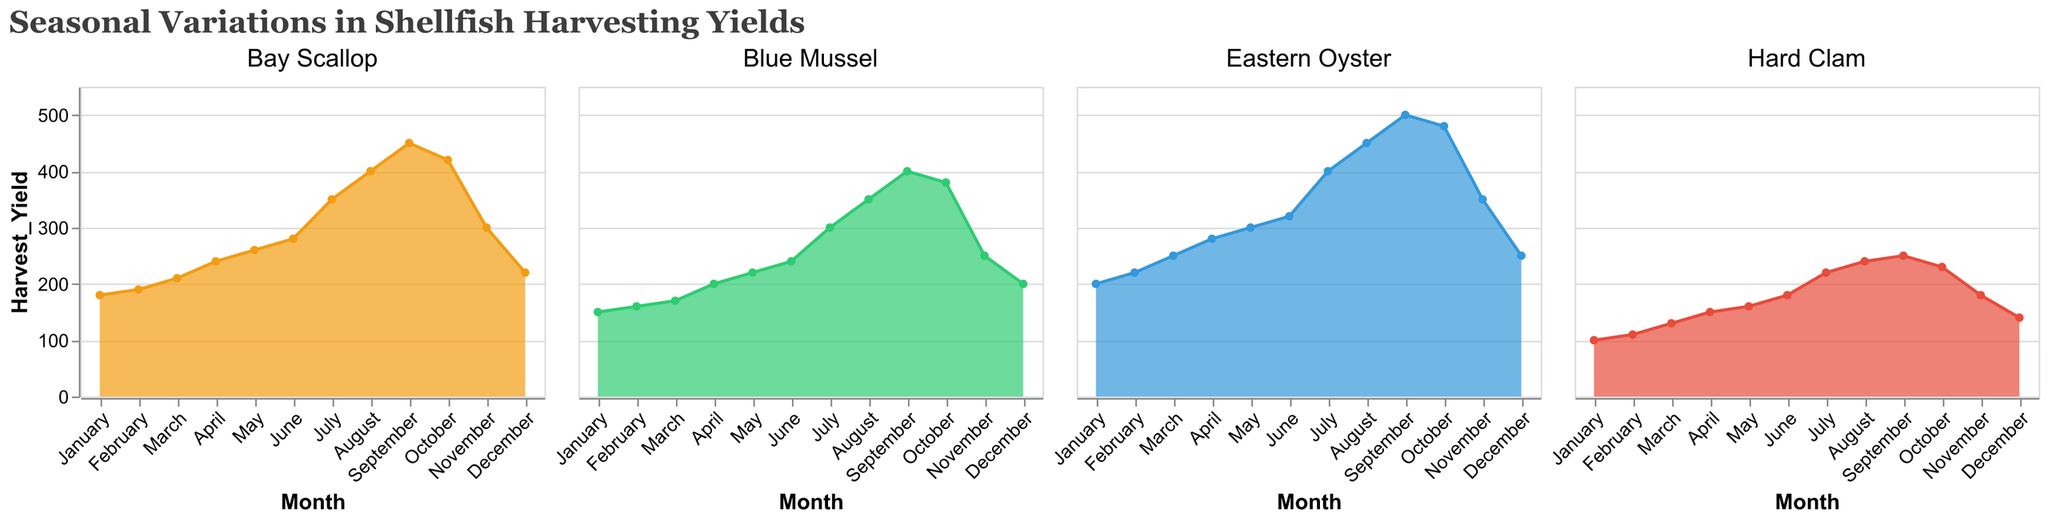What is the title of the figure? The title is located at the top of the figure and reads "Seasonal Variations in Shellfish Harvesting Yields".
Answer: Seasonal Variations in Shellfish Harvesting Yields What months show the highest harvest yield for Eastern Oyster? By inspecting the plot for Eastern Oyster, we see the harvest yield is the highest during the months of August and September.
Answer: August and September How does the harvest yield of Blue Mussel in July compare to its yield in December? Looking at the Blue Mussel subplot, the harvest yield in July is 300 and in December it is 200, showing that July's yield is higher.
Answer: July's yield is higher Which species has the lowest harvest yield in January? By comparing the January yields across all four subplots, Hard Clam has the lowest value of 100.
Answer: Hard Clam What is the average harvest yield of Bay Scallop for the months of June, July, and August? The yields for Bay Scallop are: June 280, July 350, and August 400. Summing these yields gives 1030, and dividing by 3 gives an average yield of approximately 343.33.
Answer: 343.33 Between Bay Scallop and Hard Clam, which species shows a higher yield in November? Checking November data, Bay Scallop has a yield of 300, while Hard Clam has a yield of 180. Bay Scallop has the higher yield.
Answer: Bay Scallop What is the total harvest yield of Eastern Oyster from June to September? Yields for Eastern Oyster from June to September are: June 320, July 400, August 450, September 500. Summing these values gives 1670.
Answer: 1670 Did any species show a decreasing trend in harvest yield from September to November? Examining the trends, Bay Scallop and Eastern Oyster both show a decrease from September (450 and 500 respectively) to November (300 and 350 respectively).
Answer: Yes What are the primary colors representing each species in the chart? The species and their associated colors are: Eastern Oyster (blue), Blue Mussel (green), Hard Clam (red), Bay Scallop (orange).
Answer: Blue, Green, Red, Orange In which month is the yield for Eastern Oyster closest to the yield for Blue Mussel? The yields for Eastern Oyster and Blue Mussel are closest in June, where Eastern Oyster is 320 and Blue Mussel is 240, with a difference of 80, the smallest gap among compared months.
Answer: June 